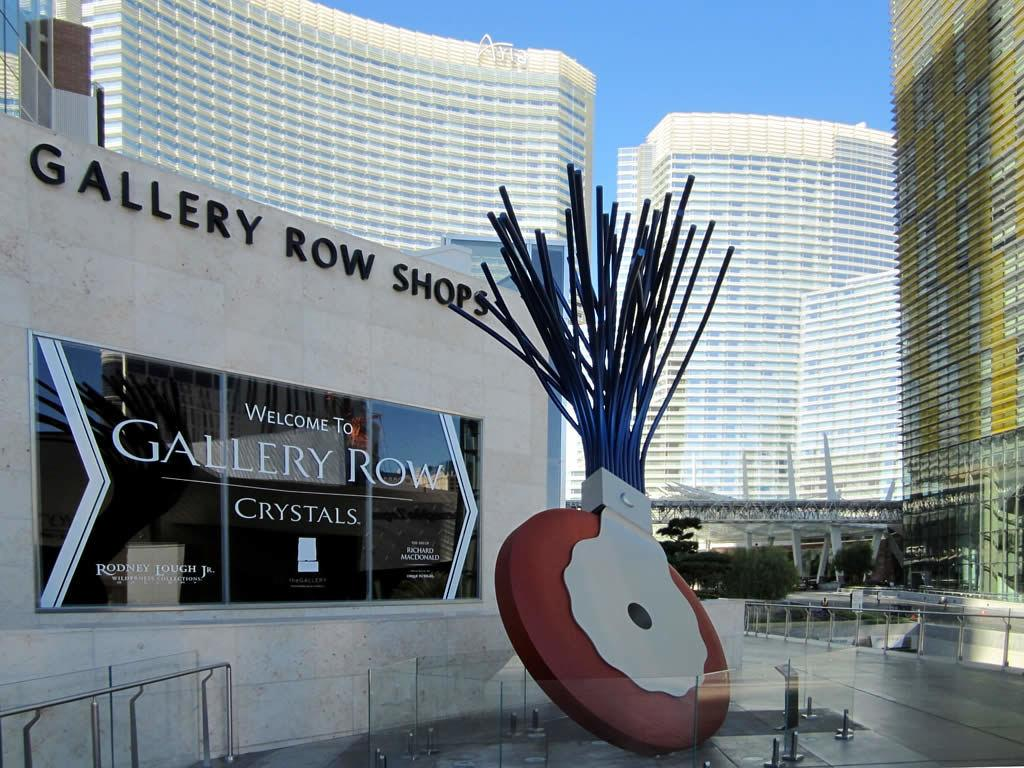What type of structures are present in the image? There are buildings in the picture. What feature can be observed on the buildings? The buildings have glass windows. What is the condition of the sky in the image? The sky is clear in the picture. What type of trousers can be seen hanging on the buildings in the image? There are no trousers visible on the buildings in the image. What type of dress is being worn by the sky in the image? The sky is not a person or entity that can wear a dress; it is a natural phenomenon. 